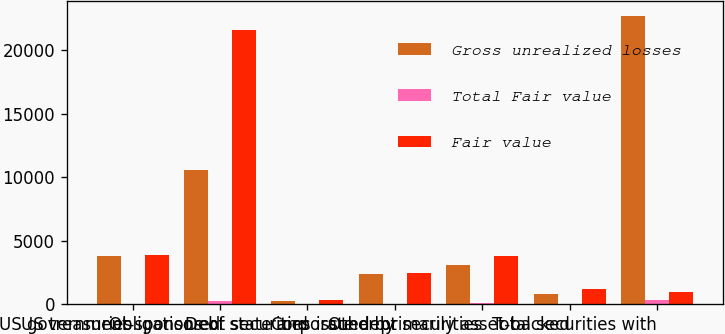Convert chart. <chart><loc_0><loc_0><loc_500><loc_500><stacked_bar_chart><ecel><fcel>US treasuries<fcel>US government-sponsored<fcel>Obligations of state and<fcel>Debt securities issued by<fcel>Corporate debt securities<fcel>Other primarily asset-backed<fcel>Total securities with<nl><fcel>Gross unrealized losses<fcel>3789<fcel>10607<fcel>237<fcel>2380<fcel>3076<fcel>778<fcel>22727<nl><fcel>Total Fair value<fcel>1<fcel>242<fcel>3<fcel>17<fcel>52<fcel>14<fcel>336<nl><fcel>Fair value<fcel>3874<fcel>21614<fcel>344<fcel>2451<fcel>3754<fcel>1148<fcel>963<nl></chart> 